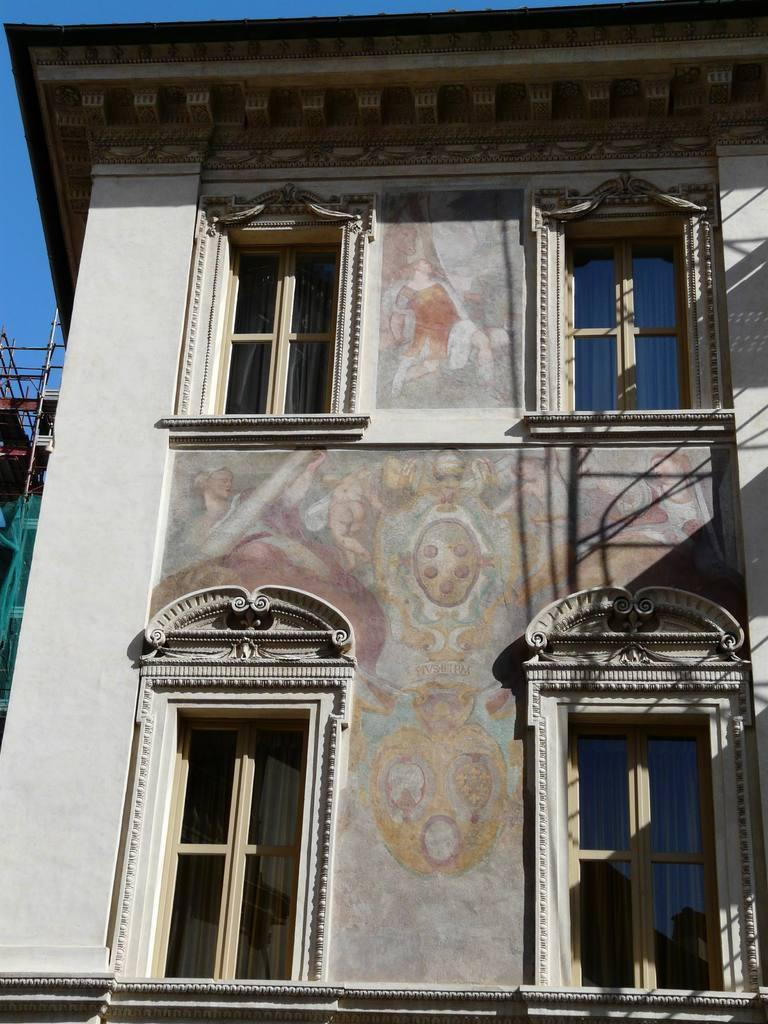What is the main subject of the image? The main subject of the image is a building. Can you describe any specific features of the building? Yes, there is some art on the building, and there are four windows on it. How many ants can be seen crawling on the wool in the image? There is no wool or ants present in the image; it features a building with art and windows. 